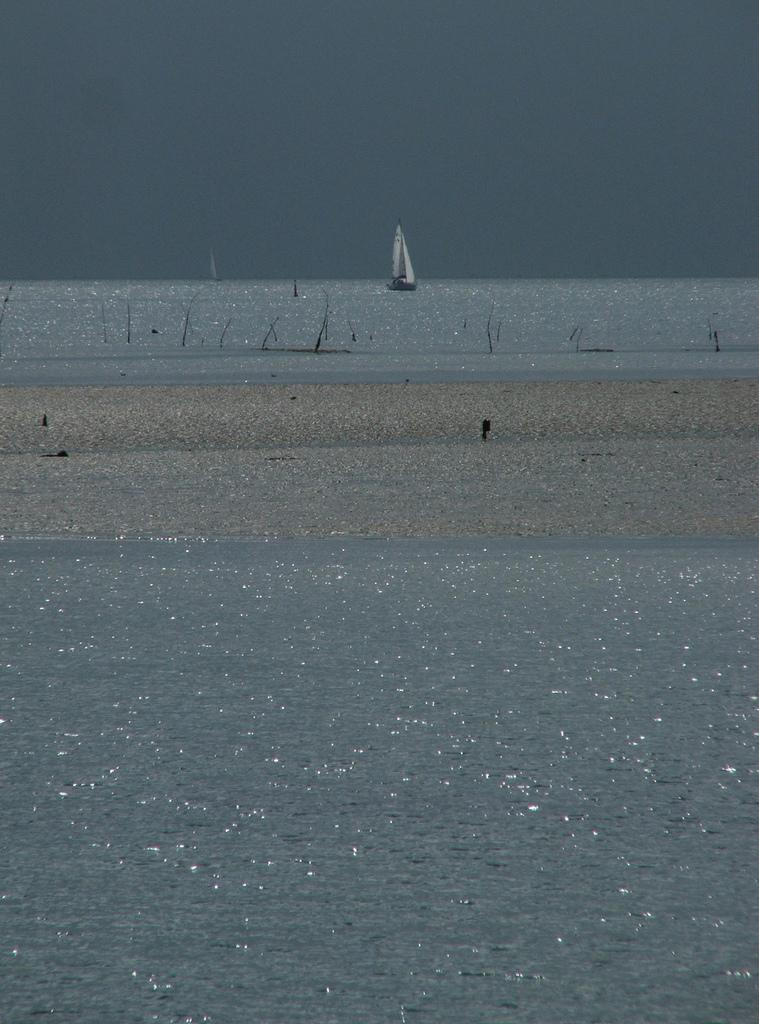What is the main subject of the image? The main subject of the image is water. What is on the water in the image? There is a boat on the water in the image. What can be seen in the background of the image? The sky is visible in the background of the image. What type of desk can be seen in the image? There is no desk present in the image; it features water and a boat. What color is the silk fabric in the image? There is no silk fabric present in the image. 